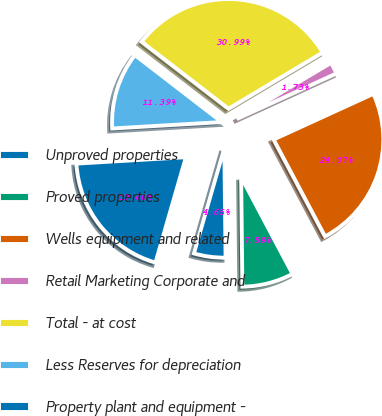<chart> <loc_0><loc_0><loc_500><loc_500><pie_chart><fcel>Unproved properties<fcel>Proved properties<fcel>Wells equipment and related<fcel>Retail Marketing Corporate and<fcel>Total - at cost<fcel>Less Reserves for depreciation<fcel>Property plant and equipment -<nl><fcel>4.65%<fcel>7.58%<fcel>24.07%<fcel>1.73%<fcel>30.99%<fcel>11.39%<fcel>19.6%<nl></chart> 